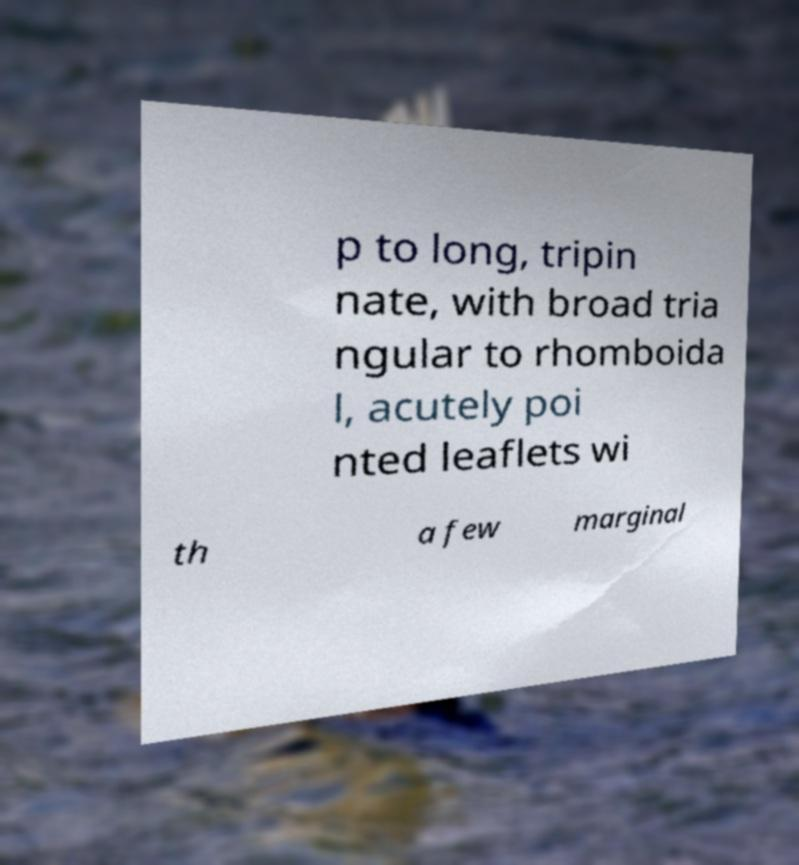For documentation purposes, I need the text within this image transcribed. Could you provide that? p to long, tripin nate, with broad tria ngular to rhomboida l, acutely poi nted leaflets wi th a few marginal 